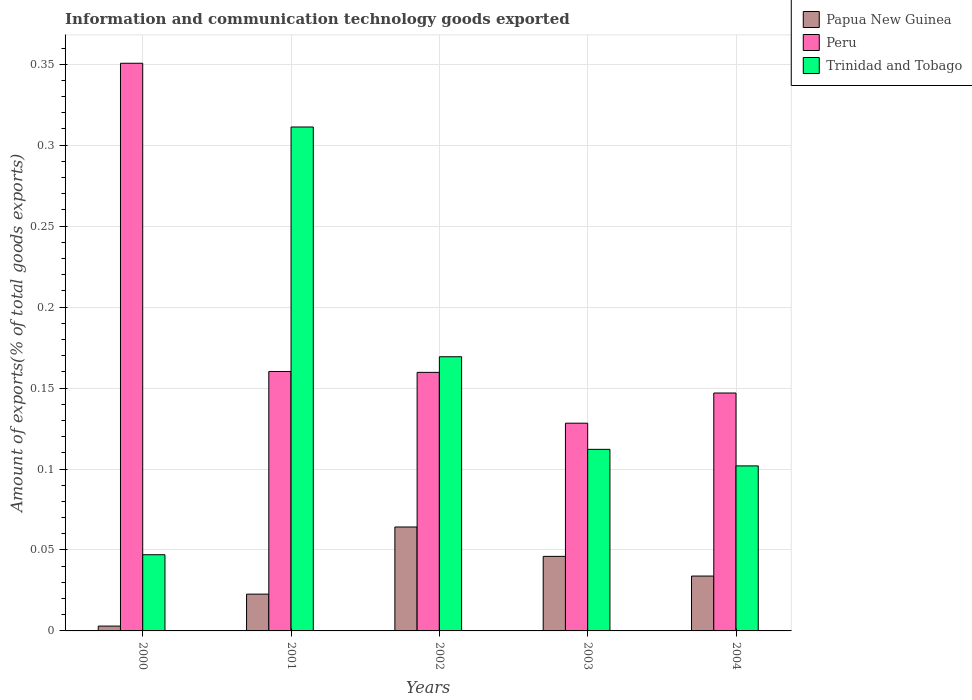Are the number of bars on each tick of the X-axis equal?
Make the answer very short. Yes. What is the amount of goods exported in Trinidad and Tobago in 2002?
Make the answer very short. 0.17. Across all years, what is the maximum amount of goods exported in Papua New Guinea?
Provide a short and direct response. 0.06. Across all years, what is the minimum amount of goods exported in Papua New Guinea?
Offer a terse response. 0. In which year was the amount of goods exported in Peru maximum?
Give a very brief answer. 2000. What is the total amount of goods exported in Peru in the graph?
Ensure brevity in your answer.  0.95. What is the difference between the amount of goods exported in Trinidad and Tobago in 2000 and that in 2003?
Offer a terse response. -0.07. What is the difference between the amount of goods exported in Peru in 2000 and the amount of goods exported in Trinidad and Tobago in 2001?
Provide a short and direct response. 0.04. What is the average amount of goods exported in Trinidad and Tobago per year?
Keep it short and to the point. 0.15. In the year 2004, what is the difference between the amount of goods exported in Trinidad and Tobago and amount of goods exported in Peru?
Give a very brief answer. -0.05. In how many years, is the amount of goods exported in Peru greater than 0.09 %?
Your answer should be very brief. 5. What is the ratio of the amount of goods exported in Papua New Guinea in 2001 to that in 2003?
Provide a succinct answer. 0.49. Is the amount of goods exported in Trinidad and Tobago in 2000 less than that in 2003?
Keep it short and to the point. Yes. Is the difference between the amount of goods exported in Trinidad and Tobago in 2000 and 2001 greater than the difference between the amount of goods exported in Peru in 2000 and 2001?
Provide a short and direct response. No. What is the difference between the highest and the second highest amount of goods exported in Papua New Guinea?
Your response must be concise. 0.02. What is the difference between the highest and the lowest amount of goods exported in Papua New Guinea?
Your answer should be compact. 0.06. Is the sum of the amount of goods exported in Peru in 2000 and 2002 greater than the maximum amount of goods exported in Trinidad and Tobago across all years?
Provide a short and direct response. Yes. What does the 1st bar from the left in 2001 represents?
Your answer should be compact. Papua New Guinea. What does the 3rd bar from the right in 2004 represents?
Provide a succinct answer. Papua New Guinea. Is it the case that in every year, the sum of the amount of goods exported in Peru and amount of goods exported in Papua New Guinea is greater than the amount of goods exported in Trinidad and Tobago?
Provide a succinct answer. No. How many years are there in the graph?
Ensure brevity in your answer.  5. What is the difference between two consecutive major ticks on the Y-axis?
Make the answer very short. 0.05. Does the graph contain any zero values?
Give a very brief answer. No. How many legend labels are there?
Provide a short and direct response. 3. How are the legend labels stacked?
Your answer should be very brief. Vertical. What is the title of the graph?
Your answer should be very brief. Information and communication technology goods exported. What is the label or title of the X-axis?
Offer a very short reply. Years. What is the label or title of the Y-axis?
Make the answer very short. Amount of exports(% of total goods exports). What is the Amount of exports(% of total goods exports) in Papua New Guinea in 2000?
Ensure brevity in your answer.  0. What is the Amount of exports(% of total goods exports) in Peru in 2000?
Your response must be concise. 0.35. What is the Amount of exports(% of total goods exports) in Trinidad and Tobago in 2000?
Give a very brief answer. 0.05. What is the Amount of exports(% of total goods exports) in Papua New Guinea in 2001?
Make the answer very short. 0.02. What is the Amount of exports(% of total goods exports) in Peru in 2001?
Your answer should be compact. 0.16. What is the Amount of exports(% of total goods exports) in Trinidad and Tobago in 2001?
Your answer should be compact. 0.31. What is the Amount of exports(% of total goods exports) in Papua New Guinea in 2002?
Your answer should be very brief. 0.06. What is the Amount of exports(% of total goods exports) of Peru in 2002?
Your answer should be compact. 0.16. What is the Amount of exports(% of total goods exports) in Trinidad and Tobago in 2002?
Keep it short and to the point. 0.17. What is the Amount of exports(% of total goods exports) of Papua New Guinea in 2003?
Provide a short and direct response. 0.05. What is the Amount of exports(% of total goods exports) in Peru in 2003?
Give a very brief answer. 0.13. What is the Amount of exports(% of total goods exports) of Trinidad and Tobago in 2003?
Your response must be concise. 0.11. What is the Amount of exports(% of total goods exports) in Papua New Guinea in 2004?
Your answer should be very brief. 0.03. What is the Amount of exports(% of total goods exports) in Peru in 2004?
Offer a terse response. 0.15. What is the Amount of exports(% of total goods exports) in Trinidad and Tobago in 2004?
Make the answer very short. 0.1. Across all years, what is the maximum Amount of exports(% of total goods exports) of Papua New Guinea?
Offer a very short reply. 0.06. Across all years, what is the maximum Amount of exports(% of total goods exports) of Peru?
Give a very brief answer. 0.35. Across all years, what is the maximum Amount of exports(% of total goods exports) of Trinidad and Tobago?
Make the answer very short. 0.31. Across all years, what is the minimum Amount of exports(% of total goods exports) in Papua New Guinea?
Offer a terse response. 0. Across all years, what is the minimum Amount of exports(% of total goods exports) of Peru?
Make the answer very short. 0.13. Across all years, what is the minimum Amount of exports(% of total goods exports) in Trinidad and Tobago?
Your answer should be compact. 0.05. What is the total Amount of exports(% of total goods exports) in Papua New Guinea in the graph?
Offer a terse response. 0.17. What is the total Amount of exports(% of total goods exports) of Peru in the graph?
Offer a very short reply. 0.95. What is the total Amount of exports(% of total goods exports) of Trinidad and Tobago in the graph?
Provide a short and direct response. 0.74. What is the difference between the Amount of exports(% of total goods exports) in Papua New Guinea in 2000 and that in 2001?
Your answer should be compact. -0.02. What is the difference between the Amount of exports(% of total goods exports) in Peru in 2000 and that in 2001?
Your response must be concise. 0.19. What is the difference between the Amount of exports(% of total goods exports) of Trinidad and Tobago in 2000 and that in 2001?
Make the answer very short. -0.26. What is the difference between the Amount of exports(% of total goods exports) in Papua New Guinea in 2000 and that in 2002?
Provide a short and direct response. -0.06. What is the difference between the Amount of exports(% of total goods exports) in Peru in 2000 and that in 2002?
Make the answer very short. 0.19. What is the difference between the Amount of exports(% of total goods exports) of Trinidad and Tobago in 2000 and that in 2002?
Provide a short and direct response. -0.12. What is the difference between the Amount of exports(% of total goods exports) of Papua New Guinea in 2000 and that in 2003?
Ensure brevity in your answer.  -0.04. What is the difference between the Amount of exports(% of total goods exports) in Peru in 2000 and that in 2003?
Provide a short and direct response. 0.22. What is the difference between the Amount of exports(% of total goods exports) in Trinidad and Tobago in 2000 and that in 2003?
Offer a terse response. -0.07. What is the difference between the Amount of exports(% of total goods exports) of Papua New Guinea in 2000 and that in 2004?
Your answer should be very brief. -0.03. What is the difference between the Amount of exports(% of total goods exports) of Peru in 2000 and that in 2004?
Keep it short and to the point. 0.2. What is the difference between the Amount of exports(% of total goods exports) in Trinidad and Tobago in 2000 and that in 2004?
Offer a very short reply. -0.05. What is the difference between the Amount of exports(% of total goods exports) in Papua New Guinea in 2001 and that in 2002?
Provide a succinct answer. -0.04. What is the difference between the Amount of exports(% of total goods exports) in Trinidad and Tobago in 2001 and that in 2002?
Offer a very short reply. 0.14. What is the difference between the Amount of exports(% of total goods exports) of Papua New Guinea in 2001 and that in 2003?
Keep it short and to the point. -0.02. What is the difference between the Amount of exports(% of total goods exports) of Peru in 2001 and that in 2003?
Your answer should be very brief. 0.03. What is the difference between the Amount of exports(% of total goods exports) of Trinidad and Tobago in 2001 and that in 2003?
Ensure brevity in your answer.  0.2. What is the difference between the Amount of exports(% of total goods exports) in Papua New Guinea in 2001 and that in 2004?
Give a very brief answer. -0.01. What is the difference between the Amount of exports(% of total goods exports) in Peru in 2001 and that in 2004?
Your answer should be very brief. 0.01. What is the difference between the Amount of exports(% of total goods exports) of Trinidad and Tobago in 2001 and that in 2004?
Your answer should be compact. 0.21. What is the difference between the Amount of exports(% of total goods exports) of Papua New Guinea in 2002 and that in 2003?
Give a very brief answer. 0.02. What is the difference between the Amount of exports(% of total goods exports) in Peru in 2002 and that in 2003?
Ensure brevity in your answer.  0.03. What is the difference between the Amount of exports(% of total goods exports) of Trinidad and Tobago in 2002 and that in 2003?
Ensure brevity in your answer.  0.06. What is the difference between the Amount of exports(% of total goods exports) in Papua New Guinea in 2002 and that in 2004?
Make the answer very short. 0.03. What is the difference between the Amount of exports(% of total goods exports) in Peru in 2002 and that in 2004?
Make the answer very short. 0.01. What is the difference between the Amount of exports(% of total goods exports) in Trinidad and Tobago in 2002 and that in 2004?
Keep it short and to the point. 0.07. What is the difference between the Amount of exports(% of total goods exports) of Papua New Guinea in 2003 and that in 2004?
Your response must be concise. 0.01. What is the difference between the Amount of exports(% of total goods exports) in Peru in 2003 and that in 2004?
Make the answer very short. -0.02. What is the difference between the Amount of exports(% of total goods exports) in Trinidad and Tobago in 2003 and that in 2004?
Ensure brevity in your answer.  0.01. What is the difference between the Amount of exports(% of total goods exports) in Papua New Guinea in 2000 and the Amount of exports(% of total goods exports) in Peru in 2001?
Your answer should be very brief. -0.16. What is the difference between the Amount of exports(% of total goods exports) in Papua New Guinea in 2000 and the Amount of exports(% of total goods exports) in Trinidad and Tobago in 2001?
Provide a succinct answer. -0.31. What is the difference between the Amount of exports(% of total goods exports) in Peru in 2000 and the Amount of exports(% of total goods exports) in Trinidad and Tobago in 2001?
Make the answer very short. 0.04. What is the difference between the Amount of exports(% of total goods exports) in Papua New Guinea in 2000 and the Amount of exports(% of total goods exports) in Peru in 2002?
Your response must be concise. -0.16. What is the difference between the Amount of exports(% of total goods exports) in Papua New Guinea in 2000 and the Amount of exports(% of total goods exports) in Trinidad and Tobago in 2002?
Ensure brevity in your answer.  -0.17. What is the difference between the Amount of exports(% of total goods exports) of Peru in 2000 and the Amount of exports(% of total goods exports) of Trinidad and Tobago in 2002?
Give a very brief answer. 0.18. What is the difference between the Amount of exports(% of total goods exports) of Papua New Guinea in 2000 and the Amount of exports(% of total goods exports) of Peru in 2003?
Your answer should be compact. -0.13. What is the difference between the Amount of exports(% of total goods exports) in Papua New Guinea in 2000 and the Amount of exports(% of total goods exports) in Trinidad and Tobago in 2003?
Offer a terse response. -0.11. What is the difference between the Amount of exports(% of total goods exports) of Peru in 2000 and the Amount of exports(% of total goods exports) of Trinidad and Tobago in 2003?
Make the answer very short. 0.24. What is the difference between the Amount of exports(% of total goods exports) of Papua New Guinea in 2000 and the Amount of exports(% of total goods exports) of Peru in 2004?
Offer a terse response. -0.14. What is the difference between the Amount of exports(% of total goods exports) in Papua New Guinea in 2000 and the Amount of exports(% of total goods exports) in Trinidad and Tobago in 2004?
Keep it short and to the point. -0.1. What is the difference between the Amount of exports(% of total goods exports) of Peru in 2000 and the Amount of exports(% of total goods exports) of Trinidad and Tobago in 2004?
Provide a short and direct response. 0.25. What is the difference between the Amount of exports(% of total goods exports) in Papua New Guinea in 2001 and the Amount of exports(% of total goods exports) in Peru in 2002?
Offer a very short reply. -0.14. What is the difference between the Amount of exports(% of total goods exports) in Papua New Guinea in 2001 and the Amount of exports(% of total goods exports) in Trinidad and Tobago in 2002?
Your response must be concise. -0.15. What is the difference between the Amount of exports(% of total goods exports) in Peru in 2001 and the Amount of exports(% of total goods exports) in Trinidad and Tobago in 2002?
Your response must be concise. -0.01. What is the difference between the Amount of exports(% of total goods exports) of Papua New Guinea in 2001 and the Amount of exports(% of total goods exports) of Peru in 2003?
Make the answer very short. -0.11. What is the difference between the Amount of exports(% of total goods exports) of Papua New Guinea in 2001 and the Amount of exports(% of total goods exports) of Trinidad and Tobago in 2003?
Keep it short and to the point. -0.09. What is the difference between the Amount of exports(% of total goods exports) of Peru in 2001 and the Amount of exports(% of total goods exports) of Trinidad and Tobago in 2003?
Offer a very short reply. 0.05. What is the difference between the Amount of exports(% of total goods exports) of Papua New Guinea in 2001 and the Amount of exports(% of total goods exports) of Peru in 2004?
Give a very brief answer. -0.12. What is the difference between the Amount of exports(% of total goods exports) in Papua New Guinea in 2001 and the Amount of exports(% of total goods exports) in Trinidad and Tobago in 2004?
Give a very brief answer. -0.08. What is the difference between the Amount of exports(% of total goods exports) in Peru in 2001 and the Amount of exports(% of total goods exports) in Trinidad and Tobago in 2004?
Give a very brief answer. 0.06. What is the difference between the Amount of exports(% of total goods exports) in Papua New Guinea in 2002 and the Amount of exports(% of total goods exports) in Peru in 2003?
Provide a short and direct response. -0.06. What is the difference between the Amount of exports(% of total goods exports) of Papua New Guinea in 2002 and the Amount of exports(% of total goods exports) of Trinidad and Tobago in 2003?
Your answer should be compact. -0.05. What is the difference between the Amount of exports(% of total goods exports) of Peru in 2002 and the Amount of exports(% of total goods exports) of Trinidad and Tobago in 2003?
Give a very brief answer. 0.05. What is the difference between the Amount of exports(% of total goods exports) of Papua New Guinea in 2002 and the Amount of exports(% of total goods exports) of Peru in 2004?
Give a very brief answer. -0.08. What is the difference between the Amount of exports(% of total goods exports) in Papua New Guinea in 2002 and the Amount of exports(% of total goods exports) in Trinidad and Tobago in 2004?
Offer a very short reply. -0.04. What is the difference between the Amount of exports(% of total goods exports) of Peru in 2002 and the Amount of exports(% of total goods exports) of Trinidad and Tobago in 2004?
Ensure brevity in your answer.  0.06. What is the difference between the Amount of exports(% of total goods exports) of Papua New Guinea in 2003 and the Amount of exports(% of total goods exports) of Peru in 2004?
Offer a terse response. -0.1. What is the difference between the Amount of exports(% of total goods exports) in Papua New Guinea in 2003 and the Amount of exports(% of total goods exports) in Trinidad and Tobago in 2004?
Your answer should be compact. -0.06. What is the difference between the Amount of exports(% of total goods exports) in Peru in 2003 and the Amount of exports(% of total goods exports) in Trinidad and Tobago in 2004?
Offer a very short reply. 0.03. What is the average Amount of exports(% of total goods exports) of Papua New Guinea per year?
Give a very brief answer. 0.03. What is the average Amount of exports(% of total goods exports) of Peru per year?
Ensure brevity in your answer.  0.19. What is the average Amount of exports(% of total goods exports) of Trinidad and Tobago per year?
Your answer should be compact. 0.15. In the year 2000, what is the difference between the Amount of exports(% of total goods exports) in Papua New Guinea and Amount of exports(% of total goods exports) in Peru?
Your answer should be very brief. -0.35. In the year 2000, what is the difference between the Amount of exports(% of total goods exports) of Papua New Guinea and Amount of exports(% of total goods exports) of Trinidad and Tobago?
Provide a short and direct response. -0.04. In the year 2000, what is the difference between the Amount of exports(% of total goods exports) of Peru and Amount of exports(% of total goods exports) of Trinidad and Tobago?
Make the answer very short. 0.3. In the year 2001, what is the difference between the Amount of exports(% of total goods exports) of Papua New Guinea and Amount of exports(% of total goods exports) of Peru?
Make the answer very short. -0.14. In the year 2001, what is the difference between the Amount of exports(% of total goods exports) of Papua New Guinea and Amount of exports(% of total goods exports) of Trinidad and Tobago?
Provide a short and direct response. -0.29. In the year 2001, what is the difference between the Amount of exports(% of total goods exports) in Peru and Amount of exports(% of total goods exports) in Trinidad and Tobago?
Provide a succinct answer. -0.15. In the year 2002, what is the difference between the Amount of exports(% of total goods exports) in Papua New Guinea and Amount of exports(% of total goods exports) in Peru?
Give a very brief answer. -0.1. In the year 2002, what is the difference between the Amount of exports(% of total goods exports) of Papua New Guinea and Amount of exports(% of total goods exports) of Trinidad and Tobago?
Give a very brief answer. -0.11. In the year 2002, what is the difference between the Amount of exports(% of total goods exports) of Peru and Amount of exports(% of total goods exports) of Trinidad and Tobago?
Offer a terse response. -0.01. In the year 2003, what is the difference between the Amount of exports(% of total goods exports) of Papua New Guinea and Amount of exports(% of total goods exports) of Peru?
Ensure brevity in your answer.  -0.08. In the year 2003, what is the difference between the Amount of exports(% of total goods exports) of Papua New Guinea and Amount of exports(% of total goods exports) of Trinidad and Tobago?
Provide a succinct answer. -0.07. In the year 2003, what is the difference between the Amount of exports(% of total goods exports) of Peru and Amount of exports(% of total goods exports) of Trinidad and Tobago?
Your answer should be very brief. 0.02. In the year 2004, what is the difference between the Amount of exports(% of total goods exports) of Papua New Guinea and Amount of exports(% of total goods exports) of Peru?
Give a very brief answer. -0.11. In the year 2004, what is the difference between the Amount of exports(% of total goods exports) of Papua New Guinea and Amount of exports(% of total goods exports) of Trinidad and Tobago?
Give a very brief answer. -0.07. In the year 2004, what is the difference between the Amount of exports(% of total goods exports) of Peru and Amount of exports(% of total goods exports) of Trinidad and Tobago?
Keep it short and to the point. 0.04. What is the ratio of the Amount of exports(% of total goods exports) in Papua New Guinea in 2000 to that in 2001?
Offer a terse response. 0.13. What is the ratio of the Amount of exports(% of total goods exports) of Peru in 2000 to that in 2001?
Ensure brevity in your answer.  2.19. What is the ratio of the Amount of exports(% of total goods exports) in Trinidad and Tobago in 2000 to that in 2001?
Give a very brief answer. 0.15. What is the ratio of the Amount of exports(% of total goods exports) in Papua New Guinea in 2000 to that in 2002?
Offer a terse response. 0.05. What is the ratio of the Amount of exports(% of total goods exports) of Peru in 2000 to that in 2002?
Give a very brief answer. 2.2. What is the ratio of the Amount of exports(% of total goods exports) in Trinidad and Tobago in 2000 to that in 2002?
Keep it short and to the point. 0.28. What is the ratio of the Amount of exports(% of total goods exports) of Papua New Guinea in 2000 to that in 2003?
Your answer should be compact. 0.06. What is the ratio of the Amount of exports(% of total goods exports) of Peru in 2000 to that in 2003?
Offer a very short reply. 2.73. What is the ratio of the Amount of exports(% of total goods exports) of Trinidad and Tobago in 2000 to that in 2003?
Keep it short and to the point. 0.42. What is the ratio of the Amount of exports(% of total goods exports) in Papua New Guinea in 2000 to that in 2004?
Give a very brief answer. 0.09. What is the ratio of the Amount of exports(% of total goods exports) in Peru in 2000 to that in 2004?
Your response must be concise. 2.39. What is the ratio of the Amount of exports(% of total goods exports) of Trinidad and Tobago in 2000 to that in 2004?
Your response must be concise. 0.46. What is the ratio of the Amount of exports(% of total goods exports) of Papua New Guinea in 2001 to that in 2002?
Ensure brevity in your answer.  0.35. What is the ratio of the Amount of exports(% of total goods exports) of Peru in 2001 to that in 2002?
Your response must be concise. 1. What is the ratio of the Amount of exports(% of total goods exports) of Trinidad and Tobago in 2001 to that in 2002?
Provide a succinct answer. 1.84. What is the ratio of the Amount of exports(% of total goods exports) of Papua New Guinea in 2001 to that in 2003?
Your answer should be compact. 0.49. What is the ratio of the Amount of exports(% of total goods exports) in Peru in 2001 to that in 2003?
Give a very brief answer. 1.25. What is the ratio of the Amount of exports(% of total goods exports) of Trinidad and Tobago in 2001 to that in 2003?
Keep it short and to the point. 2.78. What is the ratio of the Amount of exports(% of total goods exports) in Papua New Guinea in 2001 to that in 2004?
Your answer should be compact. 0.67. What is the ratio of the Amount of exports(% of total goods exports) of Peru in 2001 to that in 2004?
Make the answer very short. 1.09. What is the ratio of the Amount of exports(% of total goods exports) in Trinidad and Tobago in 2001 to that in 2004?
Make the answer very short. 3.05. What is the ratio of the Amount of exports(% of total goods exports) in Papua New Guinea in 2002 to that in 2003?
Your response must be concise. 1.39. What is the ratio of the Amount of exports(% of total goods exports) of Peru in 2002 to that in 2003?
Give a very brief answer. 1.24. What is the ratio of the Amount of exports(% of total goods exports) in Trinidad and Tobago in 2002 to that in 2003?
Your answer should be compact. 1.51. What is the ratio of the Amount of exports(% of total goods exports) in Papua New Guinea in 2002 to that in 2004?
Give a very brief answer. 1.89. What is the ratio of the Amount of exports(% of total goods exports) in Peru in 2002 to that in 2004?
Your answer should be compact. 1.09. What is the ratio of the Amount of exports(% of total goods exports) in Trinidad and Tobago in 2002 to that in 2004?
Your response must be concise. 1.66. What is the ratio of the Amount of exports(% of total goods exports) of Papua New Guinea in 2003 to that in 2004?
Make the answer very short. 1.36. What is the ratio of the Amount of exports(% of total goods exports) of Peru in 2003 to that in 2004?
Provide a succinct answer. 0.87. What is the ratio of the Amount of exports(% of total goods exports) of Trinidad and Tobago in 2003 to that in 2004?
Offer a terse response. 1.1. What is the difference between the highest and the second highest Amount of exports(% of total goods exports) in Papua New Guinea?
Offer a very short reply. 0.02. What is the difference between the highest and the second highest Amount of exports(% of total goods exports) in Peru?
Ensure brevity in your answer.  0.19. What is the difference between the highest and the second highest Amount of exports(% of total goods exports) of Trinidad and Tobago?
Make the answer very short. 0.14. What is the difference between the highest and the lowest Amount of exports(% of total goods exports) of Papua New Guinea?
Your answer should be compact. 0.06. What is the difference between the highest and the lowest Amount of exports(% of total goods exports) in Peru?
Ensure brevity in your answer.  0.22. What is the difference between the highest and the lowest Amount of exports(% of total goods exports) in Trinidad and Tobago?
Your answer should be compact. 0.26. 